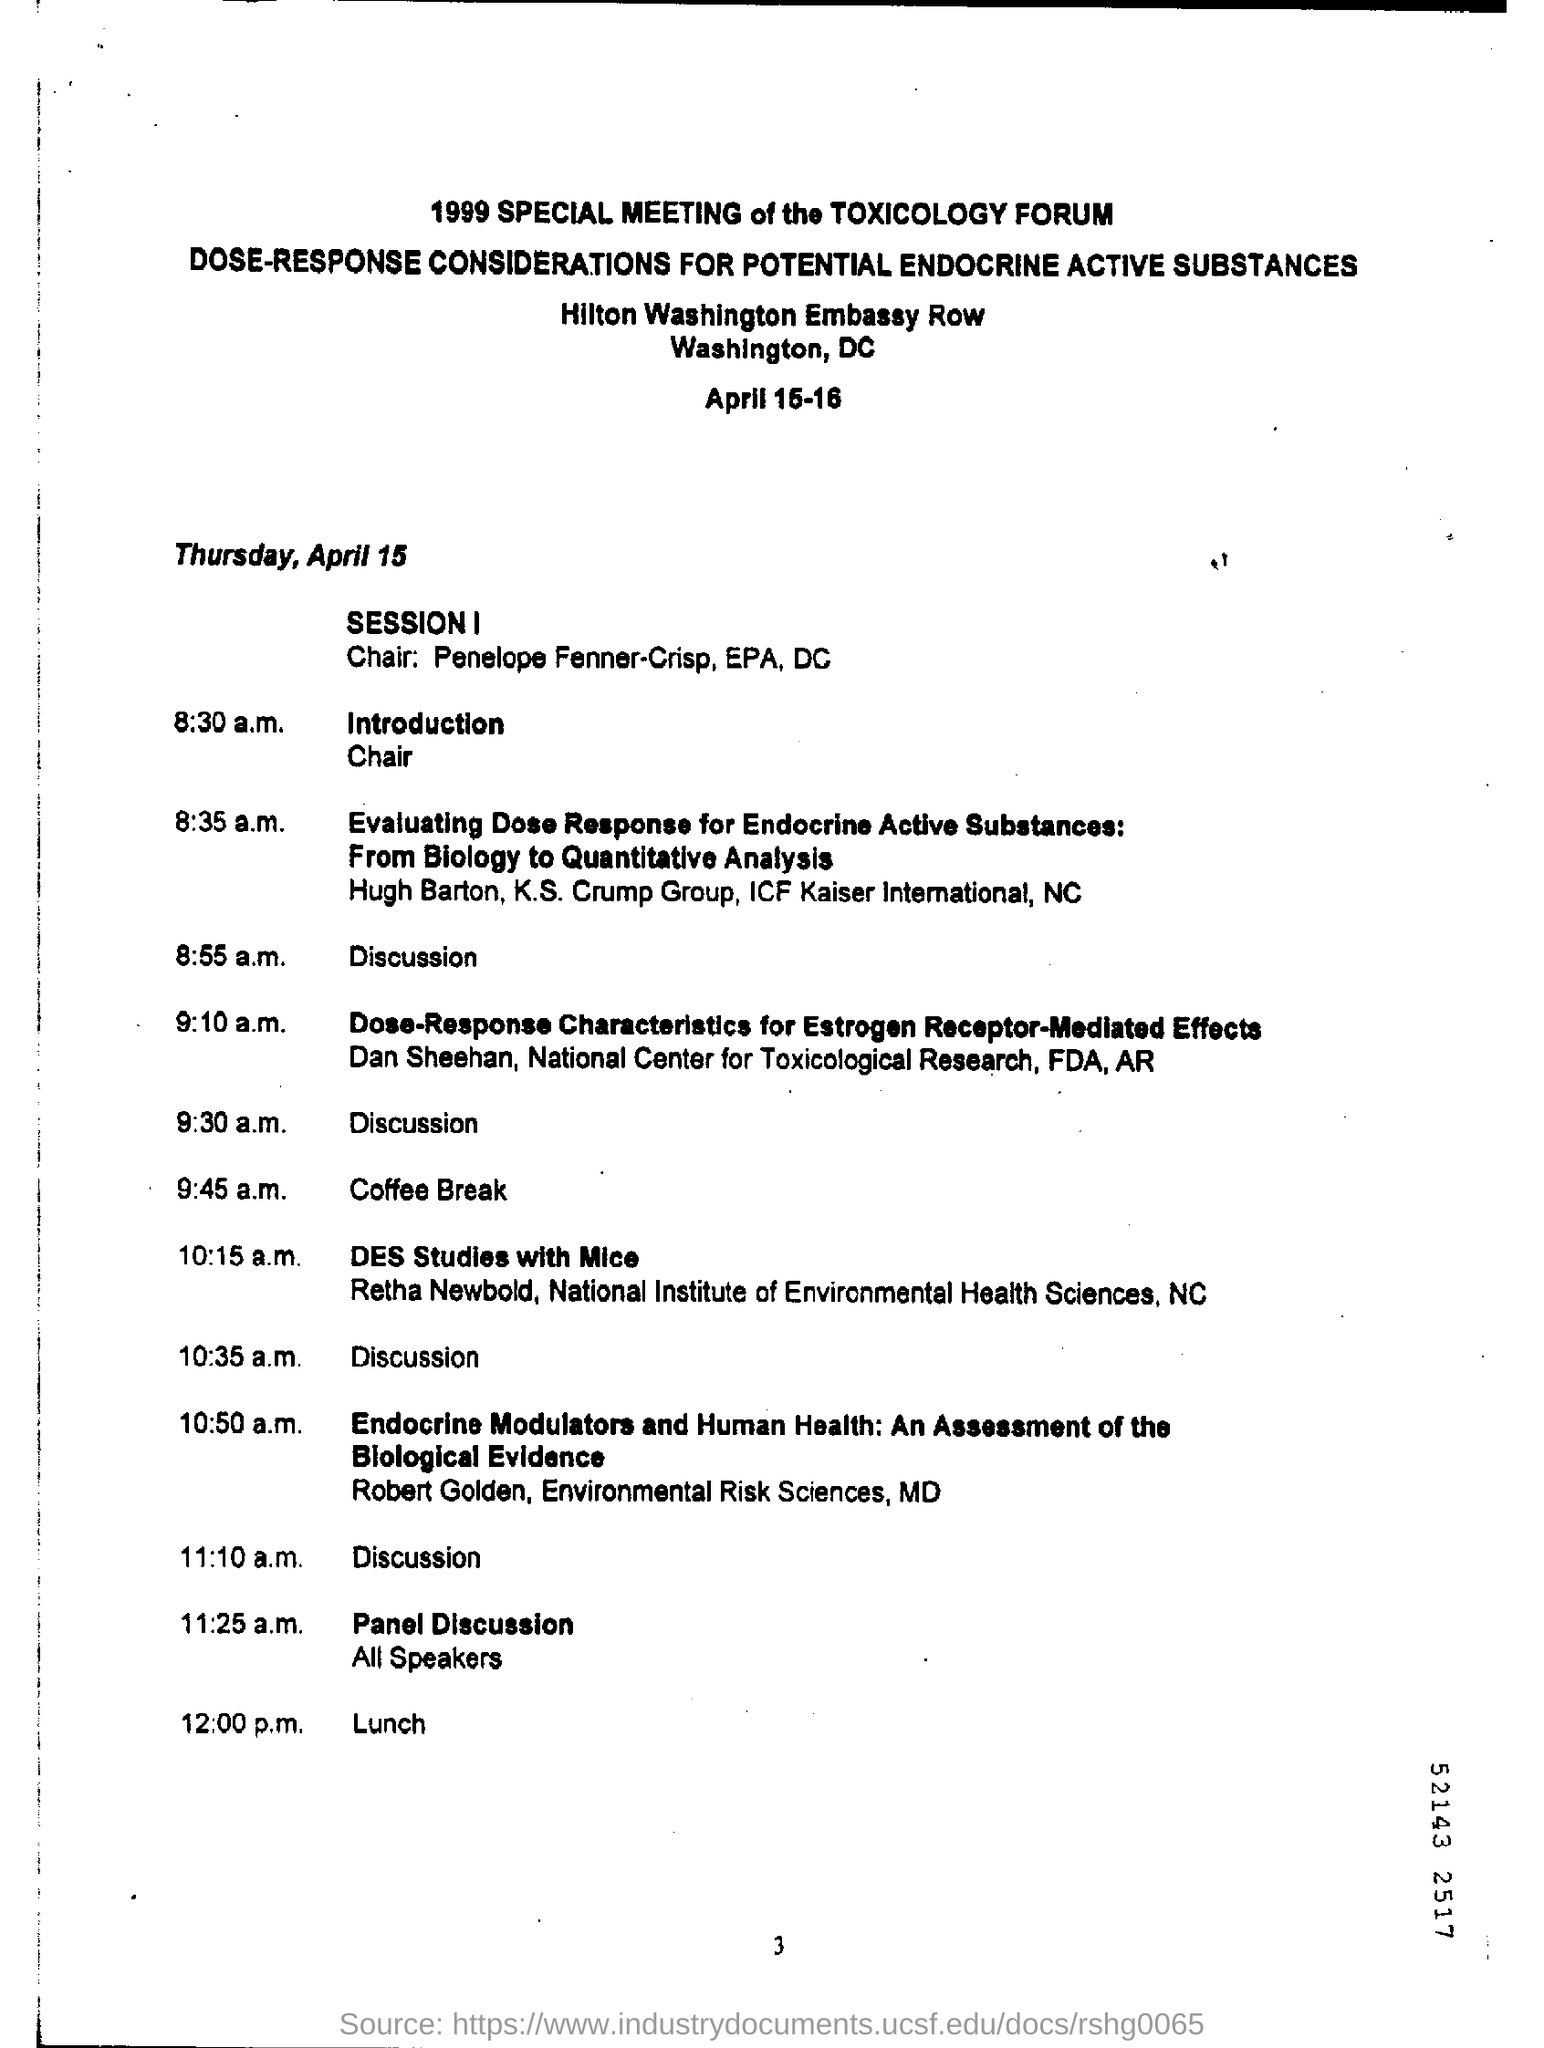Mention a couple of crucial points in this snapshot. The panel discussion is scheduled to take place at 11:25 a.m. The introduction will take place at 8:30 a.m. 